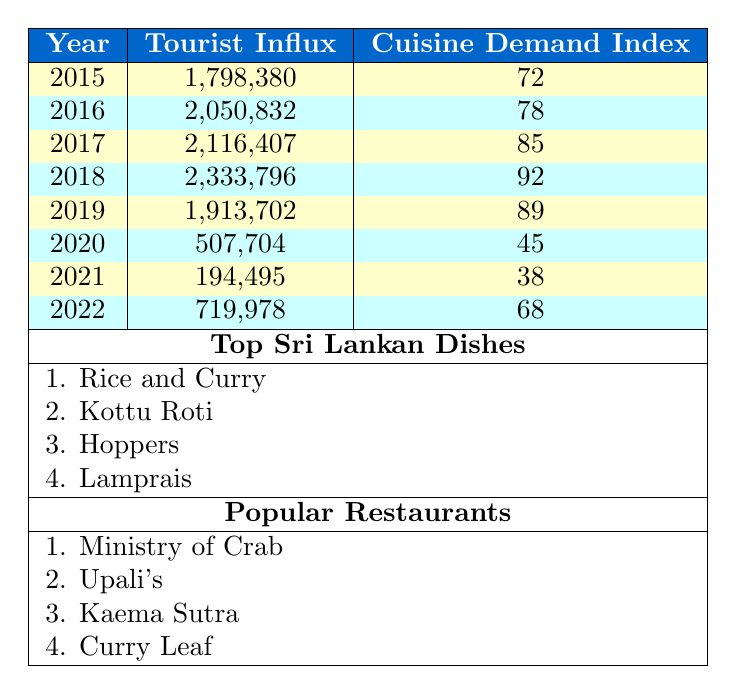What was the highest tourist influx recorded in the years shown? The highest tourist influx in the table is found in the year 2018, where the value is 2,333,796.
Answer: 2,333,796 What was the cuisine demand index for the year 2019? The cuisine demand index for 2019 is explicitly listed in the table as 89.
Answer: 89 How many years had a cuisine demand index higher than 80? The years with a cuisine demand index higher than 80 are 2017, 2018, and 2019, totaling 3 years.
Answer: 3 What is the difference between the tourist influx of 2016 and 2022? The tourist influx in 2016 is 2,050,832 and in 2022 it is 719,978. The difference is calculated as 2,050,832 - 719,978 = 1,330,854.
Answer: 1,330,854 What is the average cuisine demand index over the years provided? The cuisine demand indices are 72, 78, 85, 92, 89, 45, 38, 68. Adding them gives 72 + 78 + 85 + 92 + 89 + 45 + 38 + 68 =  597. Dividing by 8 gives an average index of 74.625, which rounds to 75.
Answer: 75 Were there any years with an influx of less than 1 million tourists? Yes, the years 2020 and 2021 both had tourist influxes of less than 1 million, specifically 507,704 and 194,495 respectively.
Answer: Yes Which year had the lowest cuisine demand index and what was the value? The lowest cuisine demand index is from 2021, which has a value of 38.
Answer: 38 What was the trend of tourist influx from 2015 to 2019? From 2015 (1,798,380) to 2018 (2,333,796), tourist influx generally increased, then fell in 2019 (1,913,702), creating a peak in 2018.
Answer: Peak in 2018, then decline in 2019 What was the corresponding cuisine demand index for the peak tourist influx year? The peak tourist influx occurred in 2018, which corresponds to a cuisine demand index of 92.
Answer: 92 How many culinary events are listed in the table? The table does not include a direct count of culinary events, but it lists 8 culinary events, consequently, there are 8 events.
Answer: 8 